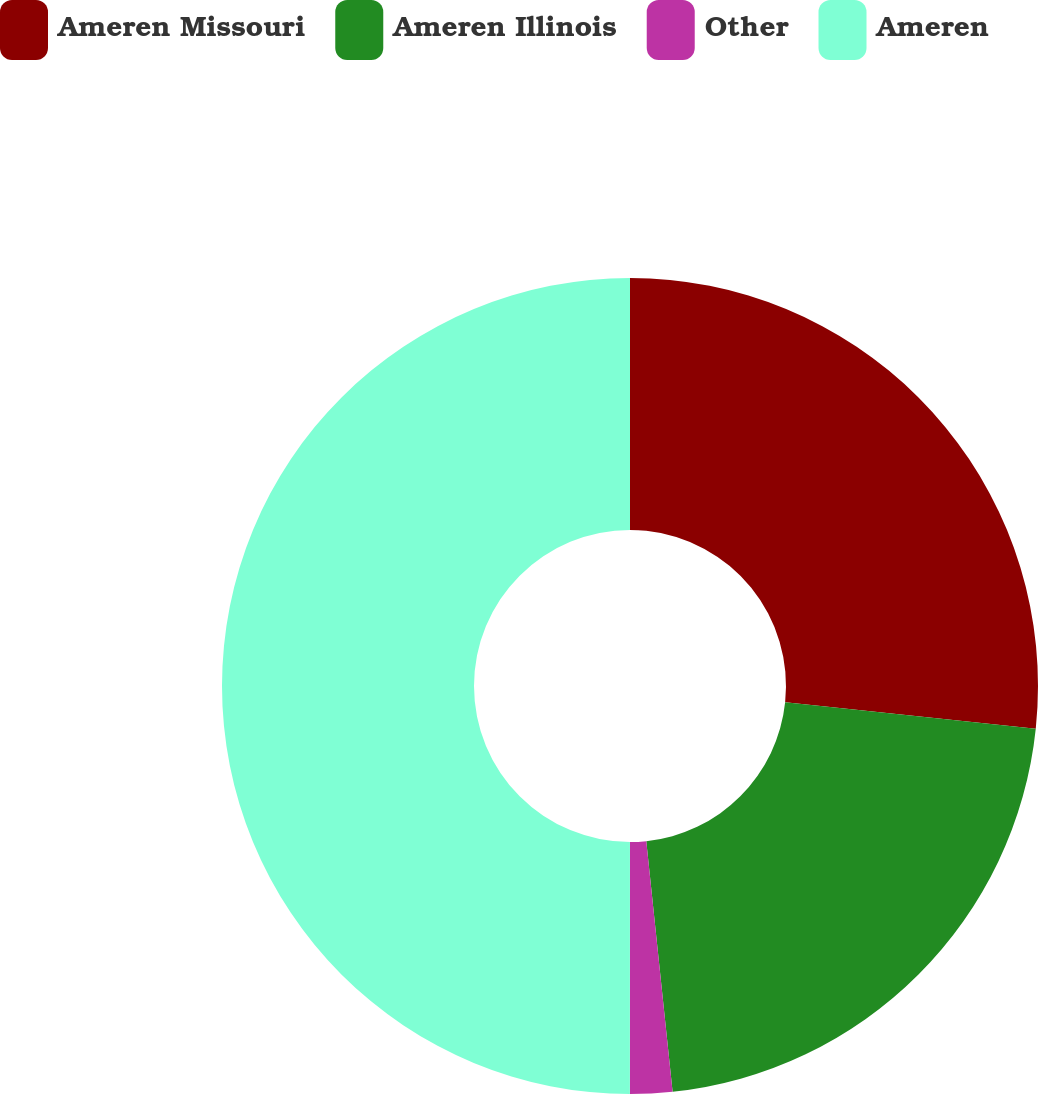<chart> <loc_0><loc_0><loc_500><loc_500><pie_chart><fcel>Ameren Missouri<fcel>Ameren Illinois<fcel>Other<fcel>Ameren<nl><fcel>26.67%<fcel>21.67%<fcel>1.67%<fcel>50.0%<nl></chart> 